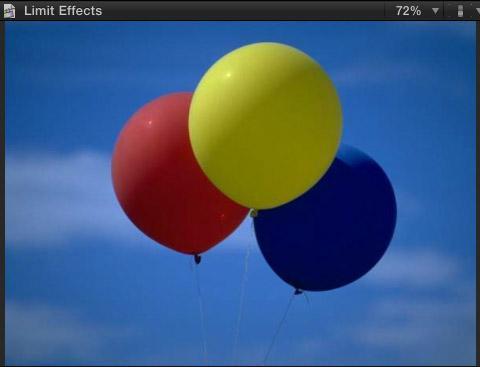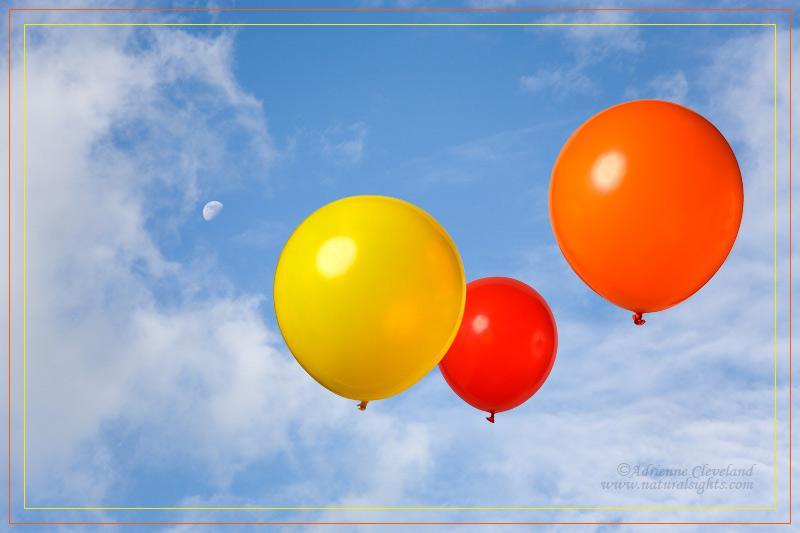The first image is the image on the left, the second image is the image on the right. For the images displayed, is the sentence "At least one of the images has a trio of balloons that represent the primary colors." factually correct? Answer yes or no. Yes. 